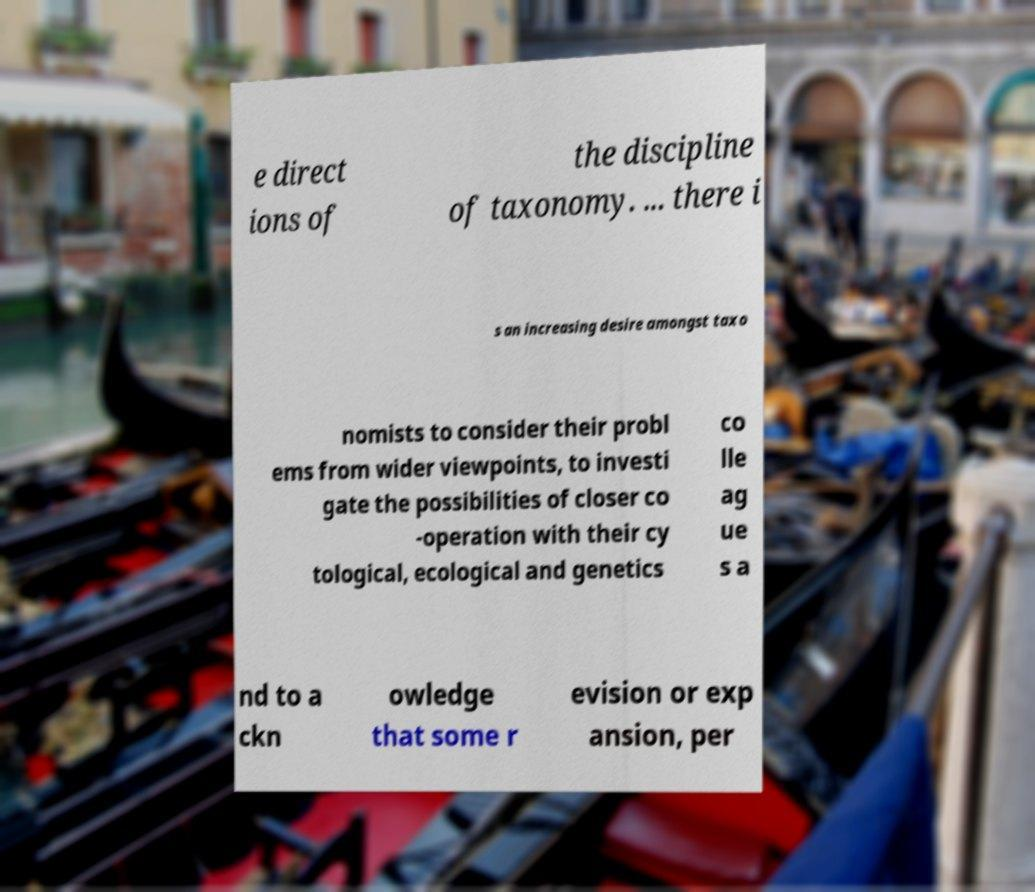Can you read and provide the text displayed in the image?This photo seems to have some interesting text. Can you extract and type it out for me? e direct ions of the discipline of taxonomy. ... there i s an increasing desire amongst taxo nomists to consider their probl ems from wider viewpoints, to investi gate the possibilities of closer co -operation with their cy tological, ecological and genetics co lle ag ue s a nd to a ckn owledge that some r evision or exp ansion, per 